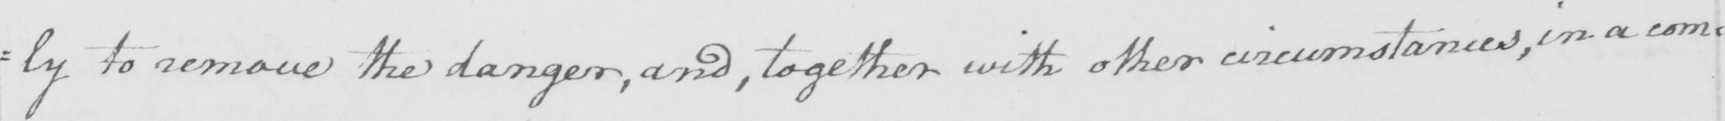Please provide the text content of this handwritten line. =ly to remove the danger , and , together with other circumstances , in a com= 